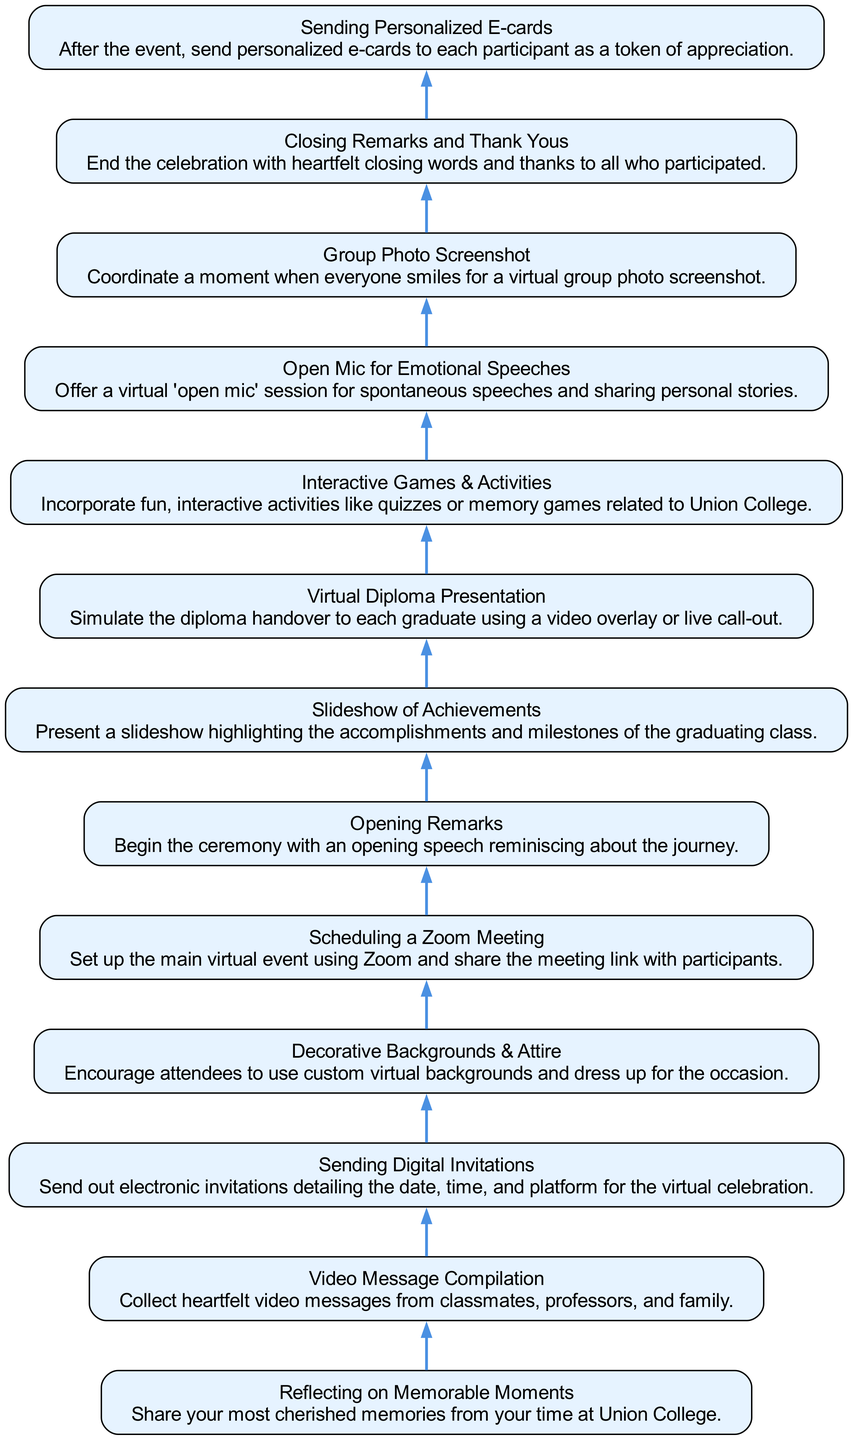What is the first step in organizing the virtual graduation celebration? The first step in the diagram, when read from bottom to up, is "Reflecting on Memorable Moments," which is listed at the bottom.
Answer: Reflecting on Memorable Moments How many total steps are there in the flow chart? By counting each unique node in the diagram, we see there are a total of 13 steps, representing the different activities to organize the celebration.
Answer: 13 What is the last action taken after the virtual graduation celebration? The final step listed at the top of the diagram is "Sending Personalized E-cards." This indicates the last action after the virtual event concludes.
Answer: Sending Personalized E-cards Which step directly follows "Video Message Compilation"? In the diagram, "Sending Digital Invitations" directly follows "Video Message Compilation," as the nodes are sequentially connected in the flow.
Answer: Sending Digital Invitations What is the purpose of the "Interactive Games & Activities" step? The description of "Interactive Games & Activities" indicates that this step is about incorporating fun, interactive activities relevant to Union College, which encourages participation.
Answer: Incorporate fun, interactive activities What connection exists between "Slideshow of Achievements" and "Virtual Diploma Presentation"? "Slideshow of Achievements" leads to "Virtual Diploma Presentation," indicating that after presenting accomplishments, the next step is to simulate the diploma handover.
Answer: Leads to What is the main platform used for the virtual celebration? The step "Scheduling a Zoom Meeting" suggests that Zoom is the primary platform selected for hosting the virtual graduation event.
Answer: Zoom How many nodes are involved in interactive activities related to the graduation? The step titled "Interactive Games & Activities" exists as a single node about fun activities and talks, indicating that this is the only node focused on such topics in the context of the event.
Answer: 1 What type of gathering is mentioned in "Open Mic for Emotional Speeches"? The phrase "virtual ‘open mic’ session" refers to an opportunity for attendees to share spontaneous speeches and personal stories in a virtual gathering format.
Answer: Virtual gathering 